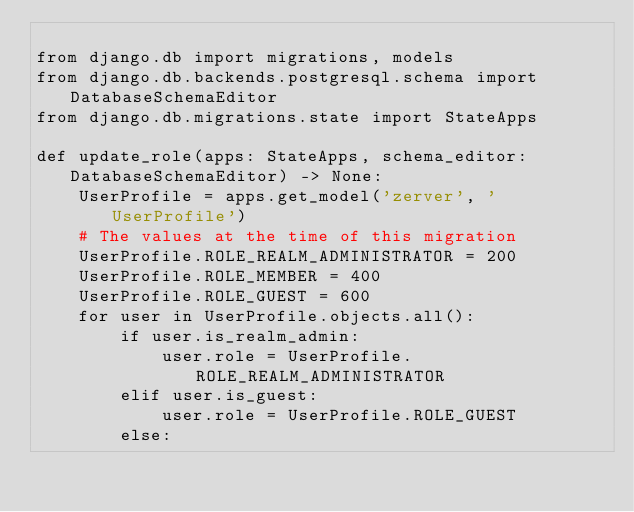<code> <loc_0><loc_0><loc_500><loc_500><_Python_>
from django.db import migrations, models
from django.db.backends.postgresql.schema import DatabaseSchemaEditor
from django.db.migrations.state import StateApps

def update_role(apps: StateApps, schema_editor: DatabaseSchemaEditor) -> None:
    UserProfile = apps.get_model('zerver', 'UserProfile')
    # The values at the time of this migration
    UserProfile.ROLE_REALM_ADMINISTRATOR = 200
    UserProfile.ROLE_MEMBER = 400
    UserProfile.ROLE_GUEST = 600
    for user in UserProfile.objects.all():
        if user.is_realm_admin:
            user.role = UserProfile.ROLE_REALM_ADMINISTRATOR
        elif user.is_guest:
            user.role = UserProfile.ROLE_GUEST
        else:</code> 